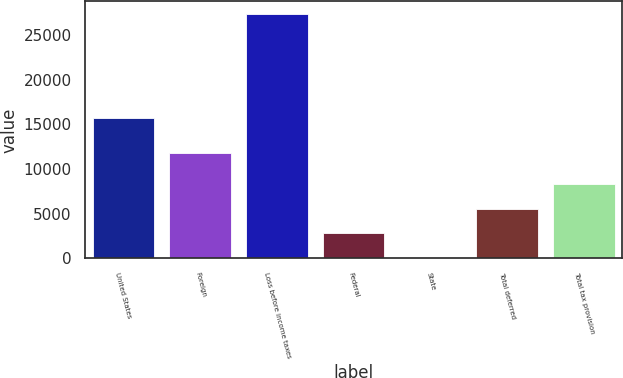Convert chart. <chart><loc_0><loc_0><loc_500><loc_500><bar_chart><fcel>United States<fcel>Foreign<fcel>Loss before income taxes<fcel>Federal<fcel>State<fcel>Total deferred<fcel>Total tax provision<nl><fcel>15660<fcel>11746<fcel>27406<fcel>2804.5<fcel>71<fcel>5538<fcel>8271.5<nl></chart> 